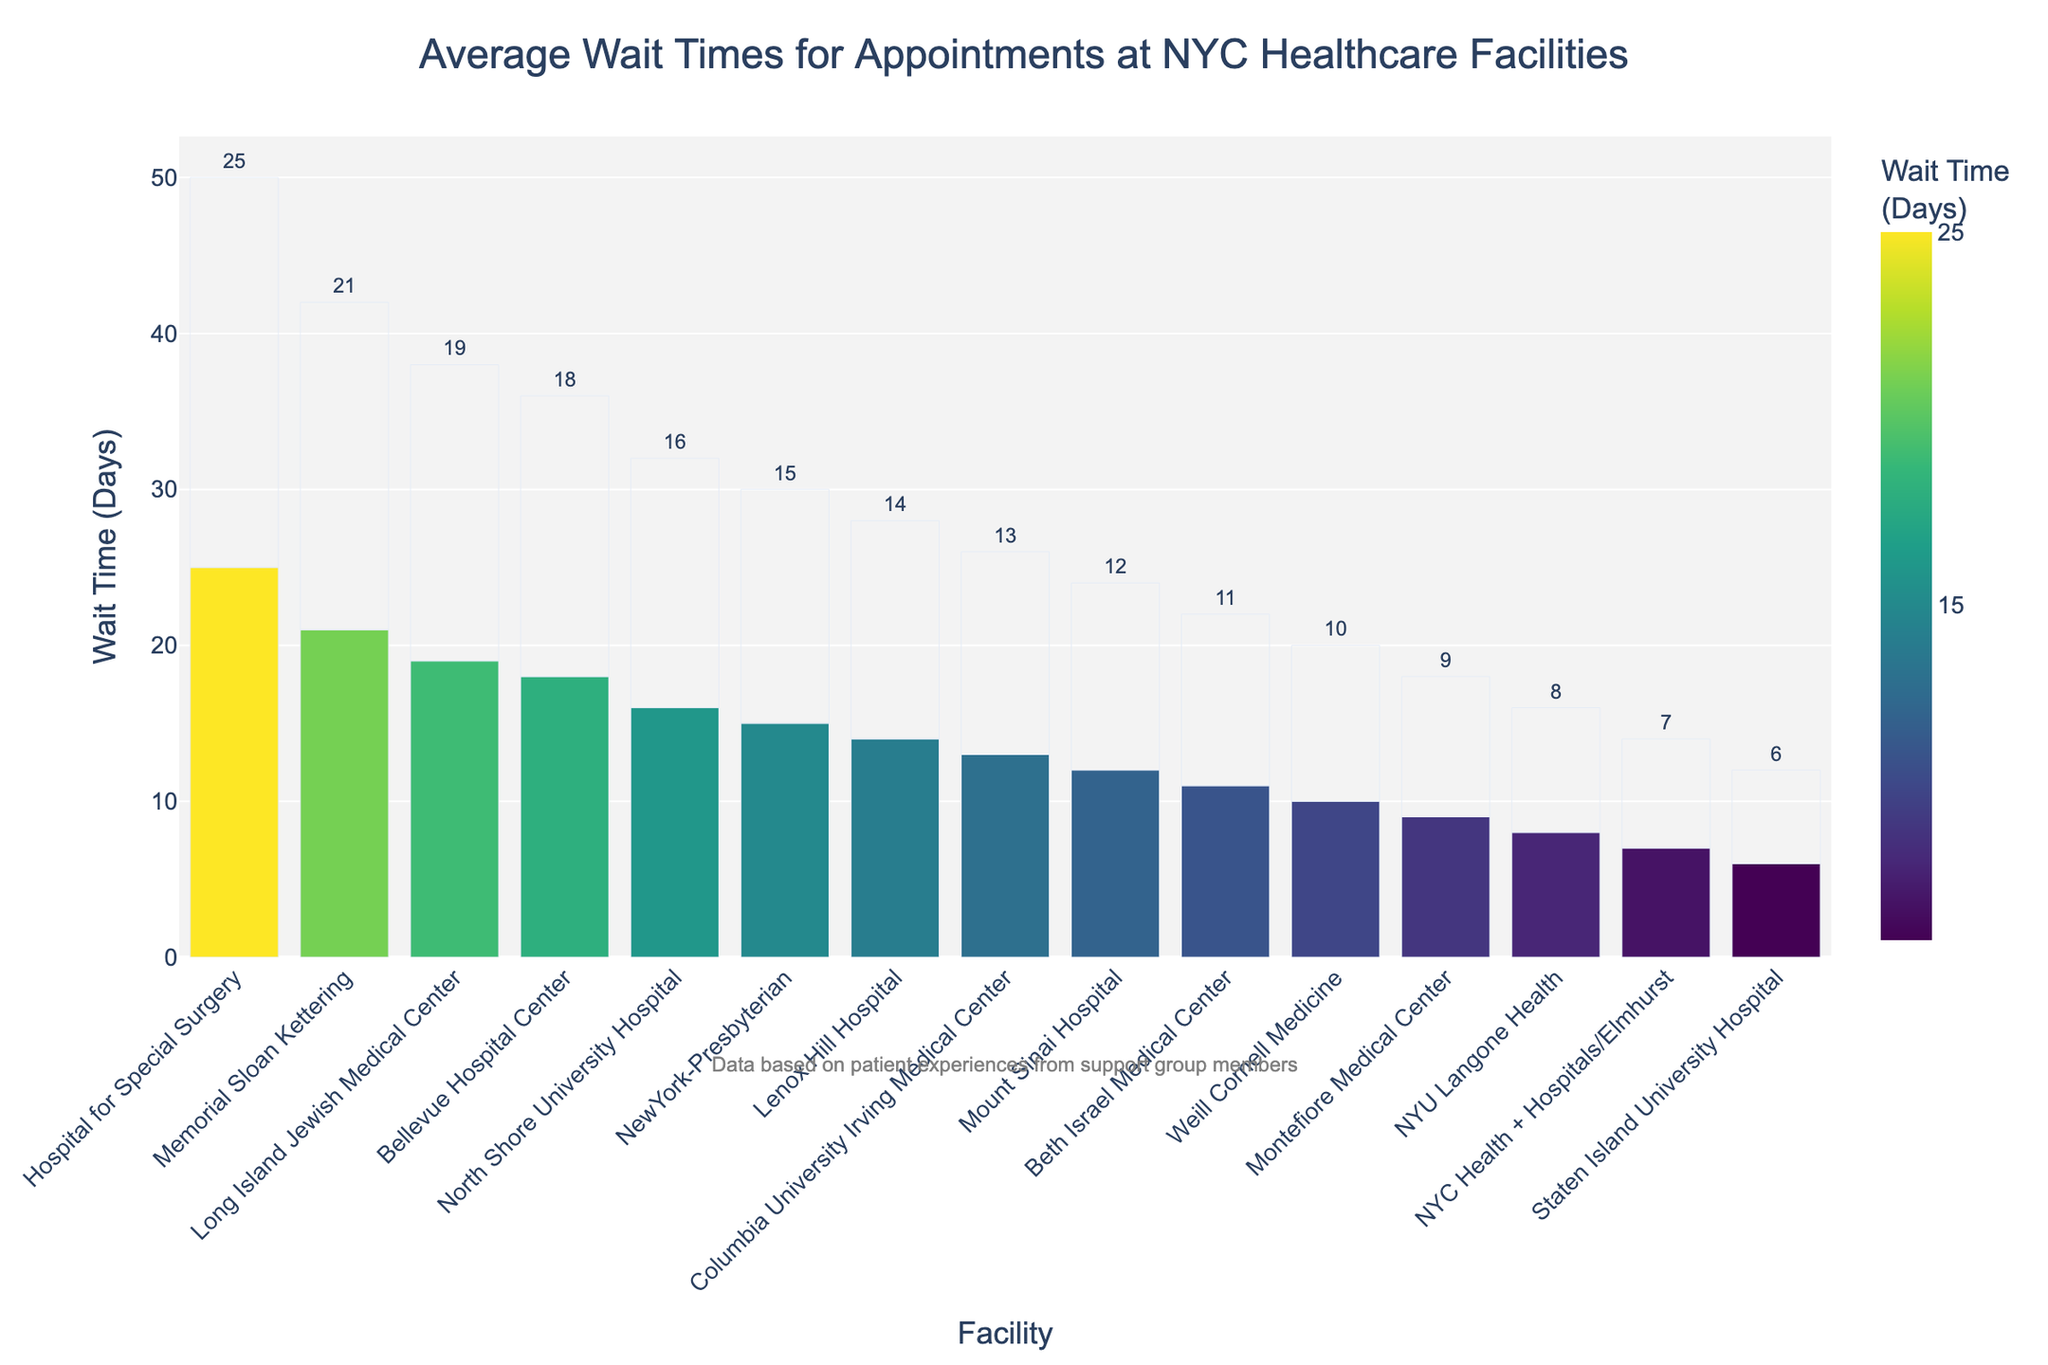What's the healthcare facility with the longest average wait time for appointments? Look at the bar height and color. The longest average wait time is represented by the tallest bar and the darkest color. Hospital for Special Surgery has the longest average wait time at 25 days.
Answer: Hospital for Special Surgery Which healthcare facility has a shorter average wait time, NYU Langone Health or Montefiore Medical Center? Compare the bar heights and colors of both facilities. NYU Langone Health has an average wait time of 8 days, while Montefiore Medical Center has an average wait time of 9 days.
Answer: NYU Langone Health What's the average wait time difference between Bellevue Hospital Center and Staten Island University Hospital? Calculate the difference in wait times by subtracting the smaller value from the larger one. Bellevue Hospital Center has a wait time of 18 days, and Staten Island University Hospital has a wait time of 6 days. The difference is 18 - 6 = 12 days.
Answer: 12 days What's the average of all the facilities' wait times shown in the bar chart? Sum all the wait times and divide by the number of facilities. 
(12 + 8 + 15 + 21 + 10 + 18 + 14 + 25 + 9 + 13 + 11 + 7 + 16 + 19 + 6) / 15 = 204 / 15 ≈ 13.6 days.
Answer: 13.6 days Which facilities have wait times less than 10 days? Look for bars with heights less than the 10-day mark. Facilities with wait times less than 10 days are: NYU Langone Health (8), Montefiore Medical Center (9), NYC Health + Hospitals/Elmhurst (7), and Staten Island University Hospital (6).
Answer: NYU Langone Health, Montefiore Medical Center, NYC Health + Hospitals/Elmhurst, Staten Island University Hospital What's the median wait time for all the facilities? Arrange all wait times in ascending order and find the middle value. Ordered wait times: [6, 7, 8, 9, 10, 11, 12, 13, 14, 15, 16, 18, 19, 21, 25]. The middle value (8th in the list) is 13.
Answer: 13 days Which color scale (darker or lighter) represents shorter wait times on the chart? Observe the color intensity associated with different wait times. Shorter wait times are represented by lighter shades, while longer wait times are represented by darker shades.
Answer: Lighter 